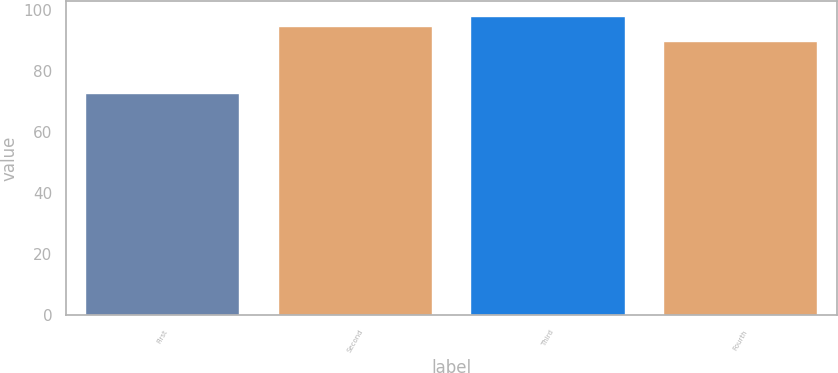<chart> <loc_0><loc_0><loc_500><loc_500><bar_chart><fcel>First<fcel>Second<fcel>Third<fcel>Fourth<nl><fcel>72.75<fcel>94.88<fcel>98.19<fcel>89.79<nl></chart> 